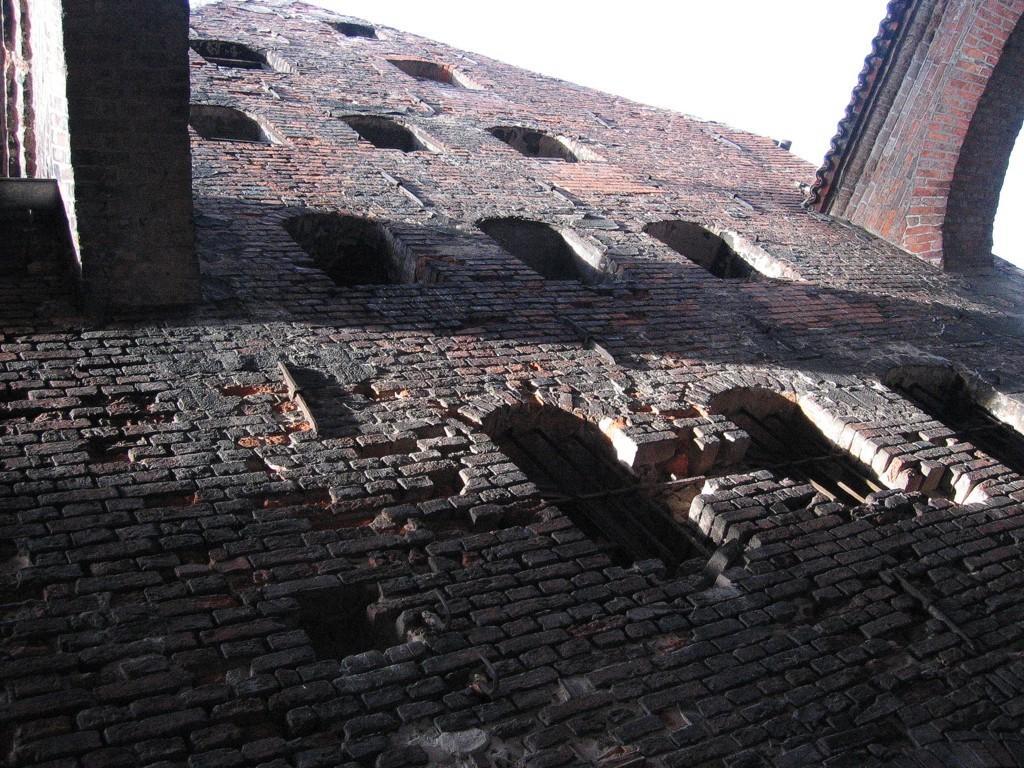Can you describe this image briefly? In this picture I can see there is a building and there two bridges here and there are some windows and the sky is clear. 